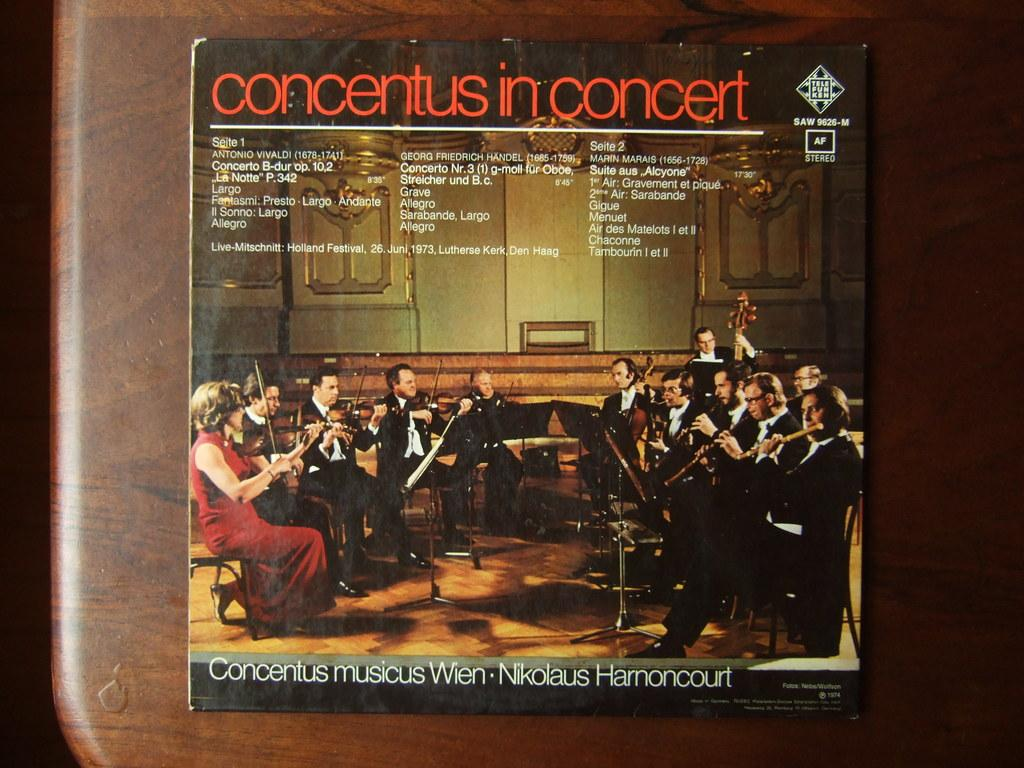What is the color of the surface in the image? The surface in the image is brown. What is placed on the brown surface? There is a paper on the brown surface. What can be seen on the paper? The paper contains images of people. What are the people in the images doing? The people are sitting and holding musical instruments in their hands. What is the chance of winning the lottery in the image? There is no mention of a lottery or any chance of winning in the image. How many attempts were made to create the images on the paper? The number of attempts made to create the images on the paper is not visible or mentioned in the image. 